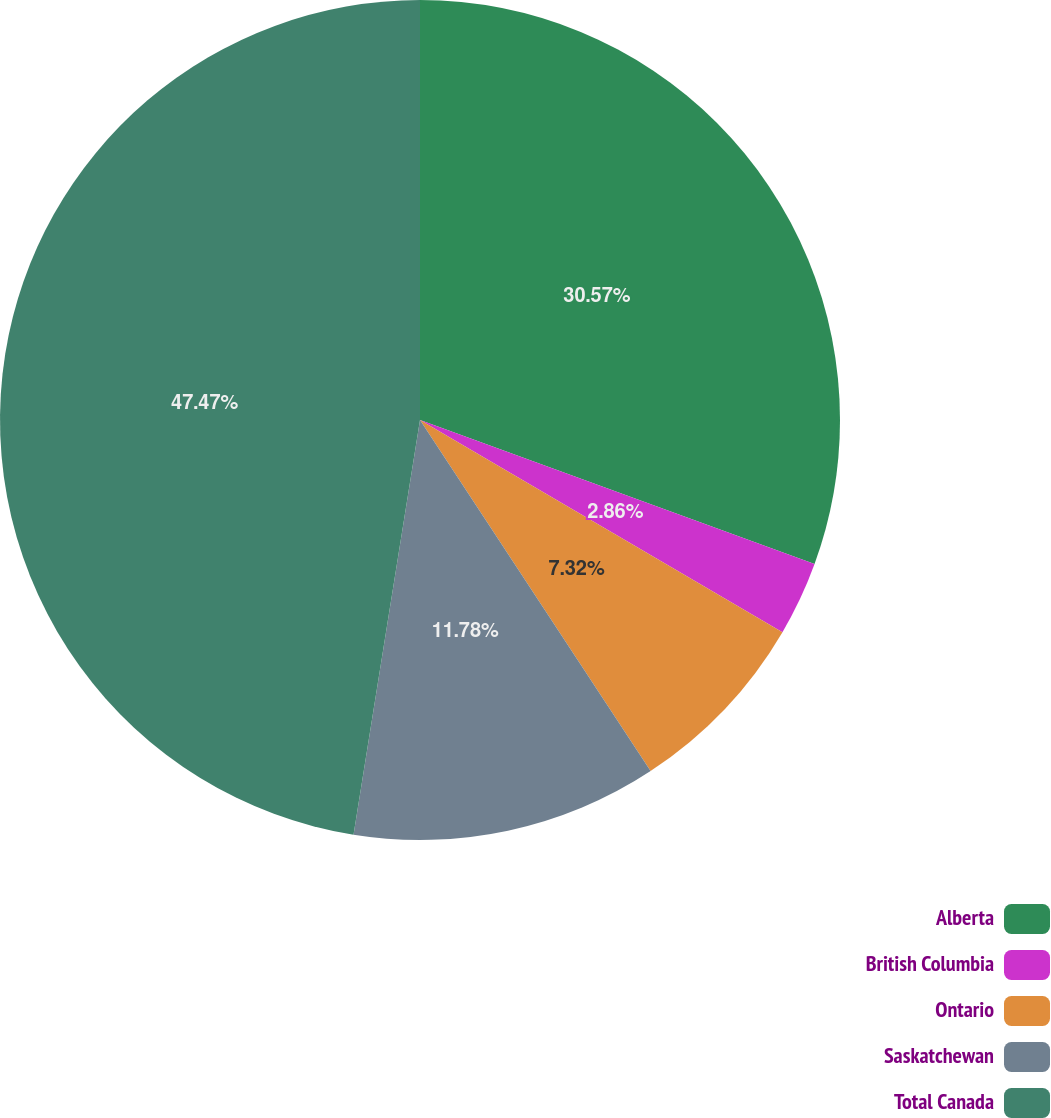Convert chart to OTSL. <chart><loc_0><loc_0><loc_500><loc_500><pie_chart><fcel>Alberta<fcel>British Columbia<fcel>Ontario<fcel>Saskatchewan<fcel>Total Canada<nl><fcel>30.57%<fcel>2.86%<fcel>7.32%<fcel>11.78%<fcel>47.47%<nl></chart> 